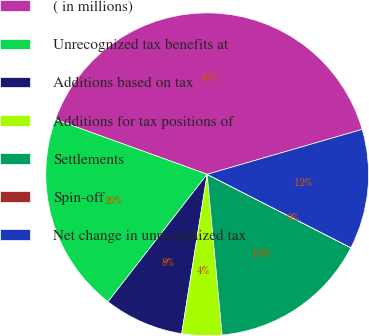Convert chart to OTSL. <chart><loc_0><loc_0><loc_500><loc_500><pie_chart><fcel>( in millions)<fcel>Unrecognized tax benefits at<fcel>Additions based on tax<fcel>Additions for tax positions of<fcel>Settlements<fcel>Spin-off<fcel>Net change in unrecognized tax<nl><fcel>39.99%<fcel>20.0%<fcel>8.0%<fcel>4.0%<fcel>16.0%<fcel>0.01%<fcel>12.0%<nl></chart> 